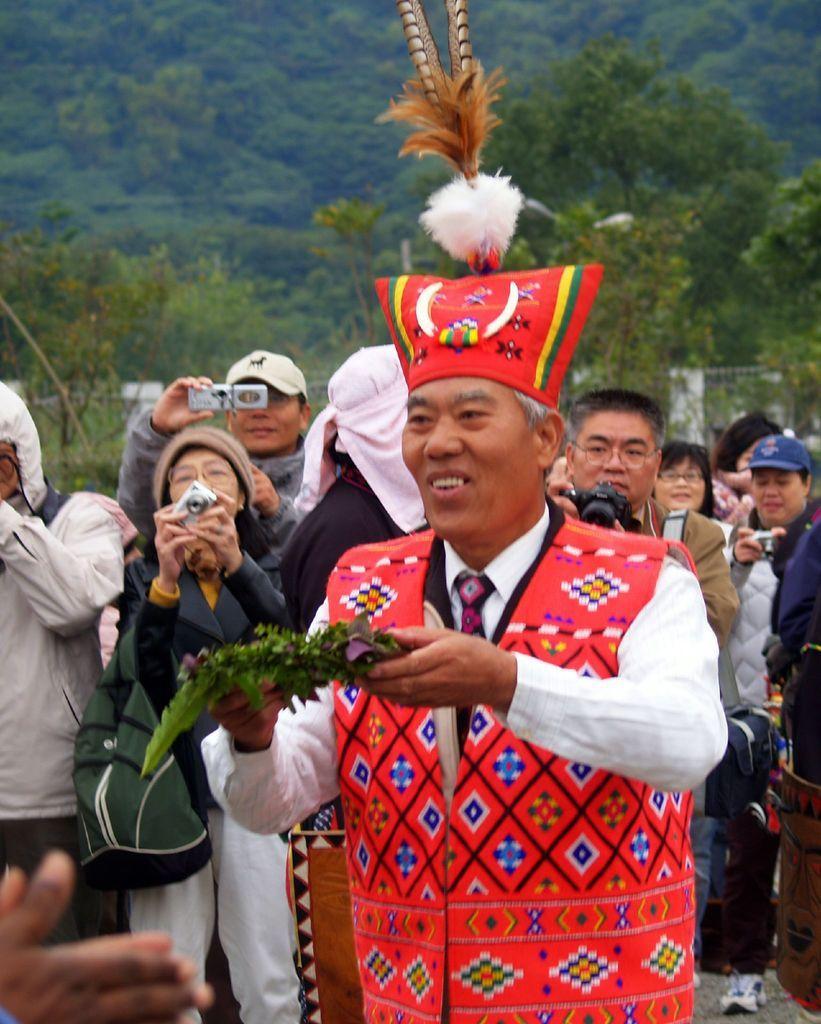How would you summarize this image in a sentence or two? In the image in the center,we can see few people were standing and smiling,which we can see on their faces. And we can see few people were holding some objects. In the background we can see trees. 